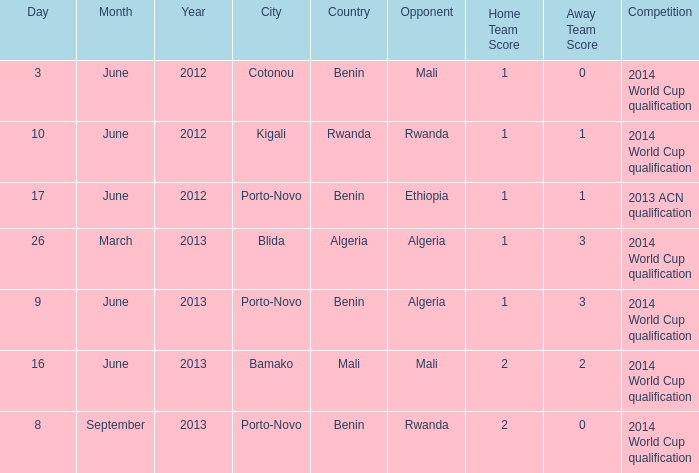What competition is located in bamako? 2014 World Cup qualification. 